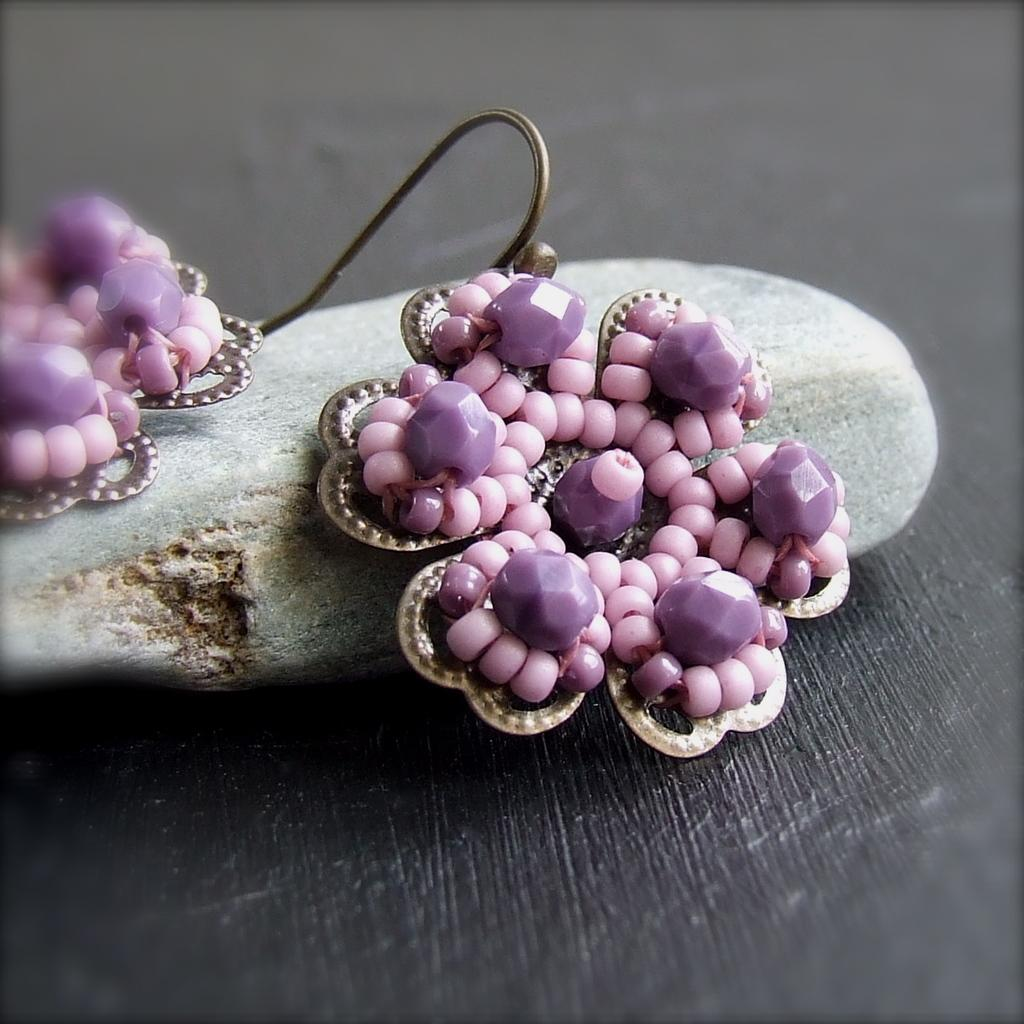What type of jewelry is visible in the image? There are earrings in the image. Where are the earrings placed? The earrings are placed on a stone. What is the stone resting on? The stone is on a wooden surface. How does the car move on the wooden surface in the image? There is no car present in the image; it only features earrings placed on a stone on a wooden surface. 